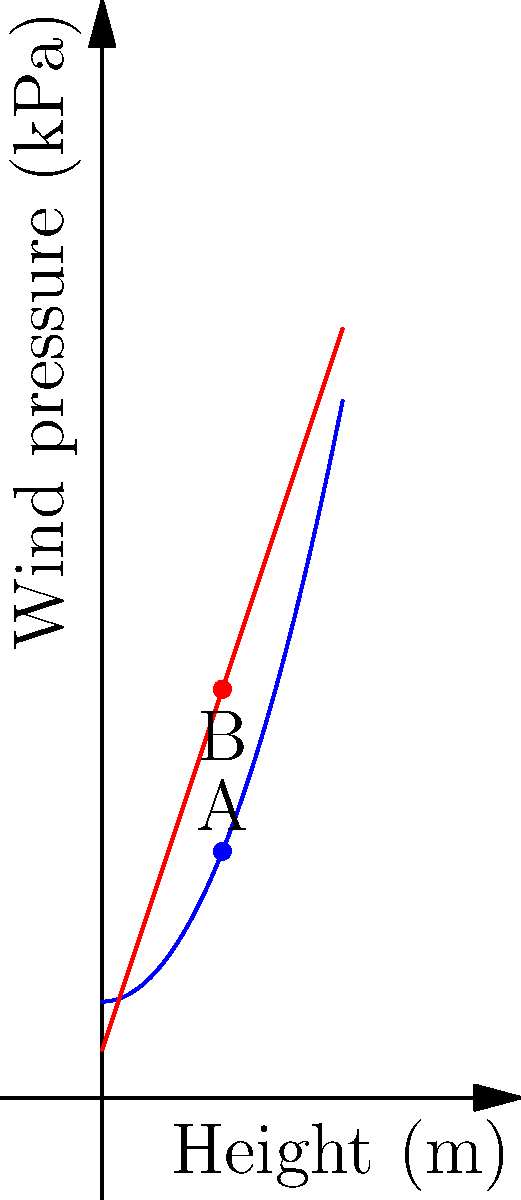As a biomechanical engineer with expertise in injury prevention, consider the wind load distribution on a high-rise building. The blue curve represents the actual wind pressure distribution, while the red line is a linear approximation. At a height of 2.5m, what is the percentage difference between the actual wind pressure (point A) and the linear approximation (point B)? To solve this problem, we'll follow these steps:

1. Determine the equations for both curves:
   - Actual wind pressure (blue): $f(x) = 0.5x^2 + 2$
   - Linear approximation (red): $g(x) = 3x + 1$

2. Calculate the wind pressure at 2.5m for both curves:
   - Actual: $f(2.5) = 0.5(2.5)^2 + 2 = 0.5(6.25) + 2 = 5.125$ kPa
   - Linear approximation: $g(2.5) = 3(2.5) + 1 = 7.5 + 1 = 8.5$ kPa

3. Calculate the difference between the two values:
   $\text{Difference} = 8.5 - 5.125 = 3.375$ kPa

4. Calculate the percentage difference:
   $\text{Percentage difference} = \frac{\text{Difference}}{\text{Actual}} \times 100\%$
   $= \frac{3.375}{5.125} \times 100\% = 65.85\%$

This significant difference highlights the importance of accurate wind load modeling in structural design, which is crucial for preventing injuries due to building failure or excessive movement during high winds.
Answer: 65.85% 